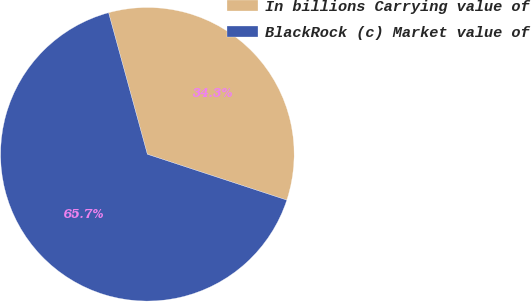Convert chart. <chart><loc_0><loc_0><loc_500><loc_500><pie_chart><fcel>In billions Carrying value of<fcel>BlackRock (c) Market value of<nl><fcel>34.31%<fcel>65.69%<nl></chart> 